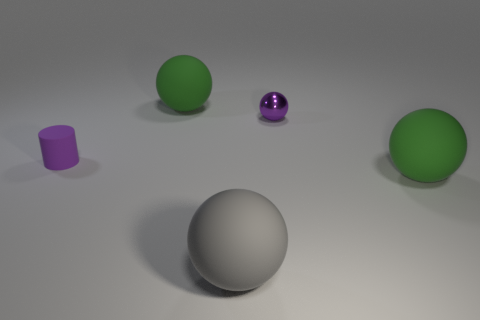How many tiny shiny objects are right of the tiny thing that is behind the tiny object in front of the small ball?
Make the answer very short. 0. Is the number of small yellow cylinders greater than the number of small purple balls?
Your response must be concise. No. What number of big gray matte balls are there?
Give a very brief answer. 1. There is a tiny object that is on the right side of the large object in front of the large matte object that is to the right of the gray thing; what is its shape?
Keep it short and to the point. Sphere. Are there fewer gray rubber spheres that are behind the metallic ball than green spheres that are behind the small rubber object?
Your response must be concise. Yes. There is a purple thing that is behind the purple rubber cylinder; does it have the same shape as the big green rubber thing that is in front of the small purple shiny thing?
Provide a succinct answer. Yes. There is a large green rubber thing right of the large rubber thing that is behind the small purple rubber cylinder; what shape is it?
Make the answer very short. Sphere. Is there a tiny green sphere that has the same material as the cylinder?
Provide a succinct answer. No. What is the material of the sphere that is behind the purple sphere?
Offer a very short reply. Rubber. What material is the purple ball?
Your answer should be compact. Metal. 